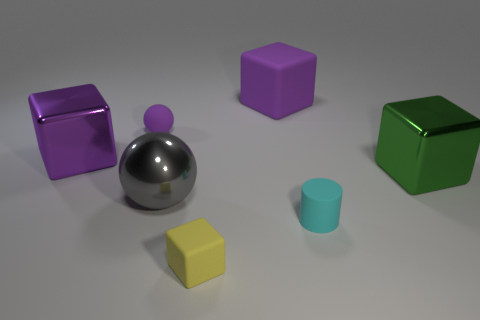There is a shiny block to the right of the small object that is behind the big metal thing that is right of the large metal ball; how big is it?
Your response must be concise. Large. There is a tiny purple thing; is it the same shape as the large metal object that is to the left of the small purple matte thing?
Ensure brevity in your answer.  No. Are there any other tiny cylinders that have the same color as the cylinder?
Provide a short and direct response. No. What number of cubes are either large gray metallic objects or tiny purple things?
Give a very brief answer. 0. Is there a purple thing of the same shape as the small cyan thing?
Your answer should be compact. No. How many other things are the same color as the tiny rubber cylinder?
Your answer should be very brief. 0. Is the number of large things that are to the right of the small yellow matte block less than the number of cyan objects?
Keep it short and to the point. No. What number of big matte things are there?
Your response must be concise. 1. What number of cubes are the same material as the purple ball?
Make the answer very short. 2. How many objects are either objects that are behind the tiny ball or tiny blue cylinders?
Your answer should be compact. 1. 